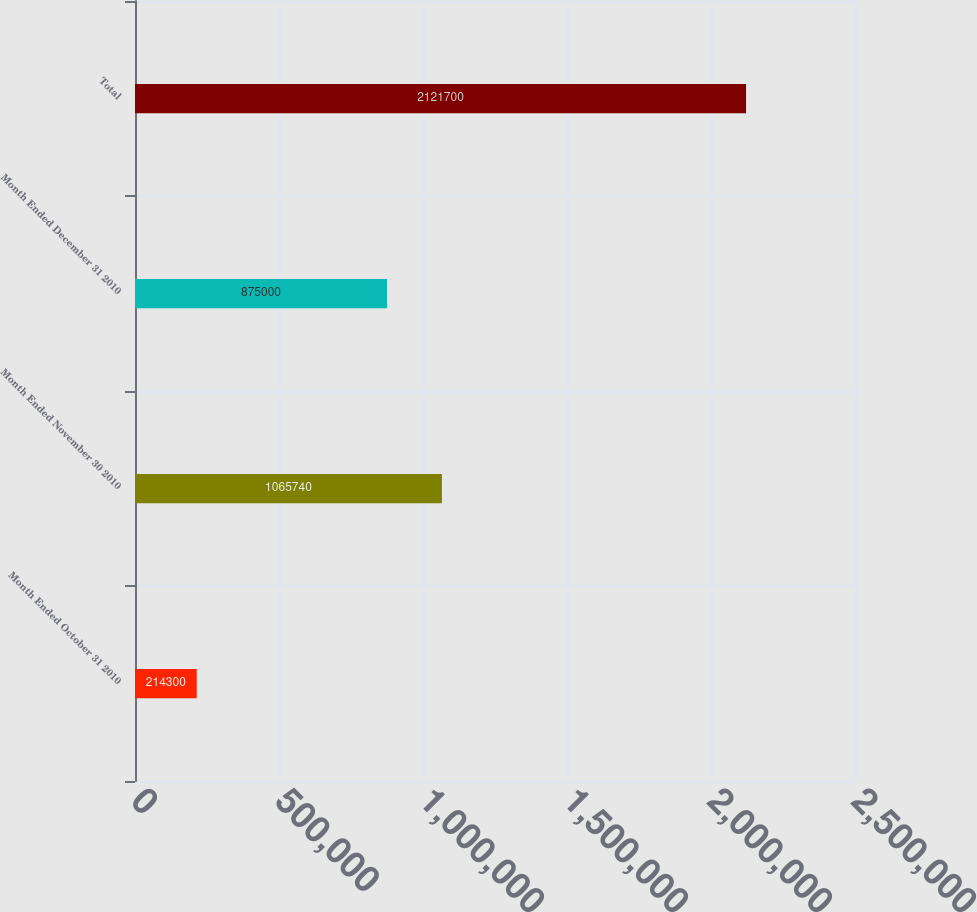Convert chart. <chart><loc_0><loc_0><loc_500><loc_500><bar_chart><fcel>Month Ended October 31 2010<fcel>Month Ended November 30 2010<fcel>Month Ended December 31 2010<fcel>Total<nl><fcel>214300<fcel>1.06574e+06<fcel>875000<fcel>2.1217e+06<nl></chart> 